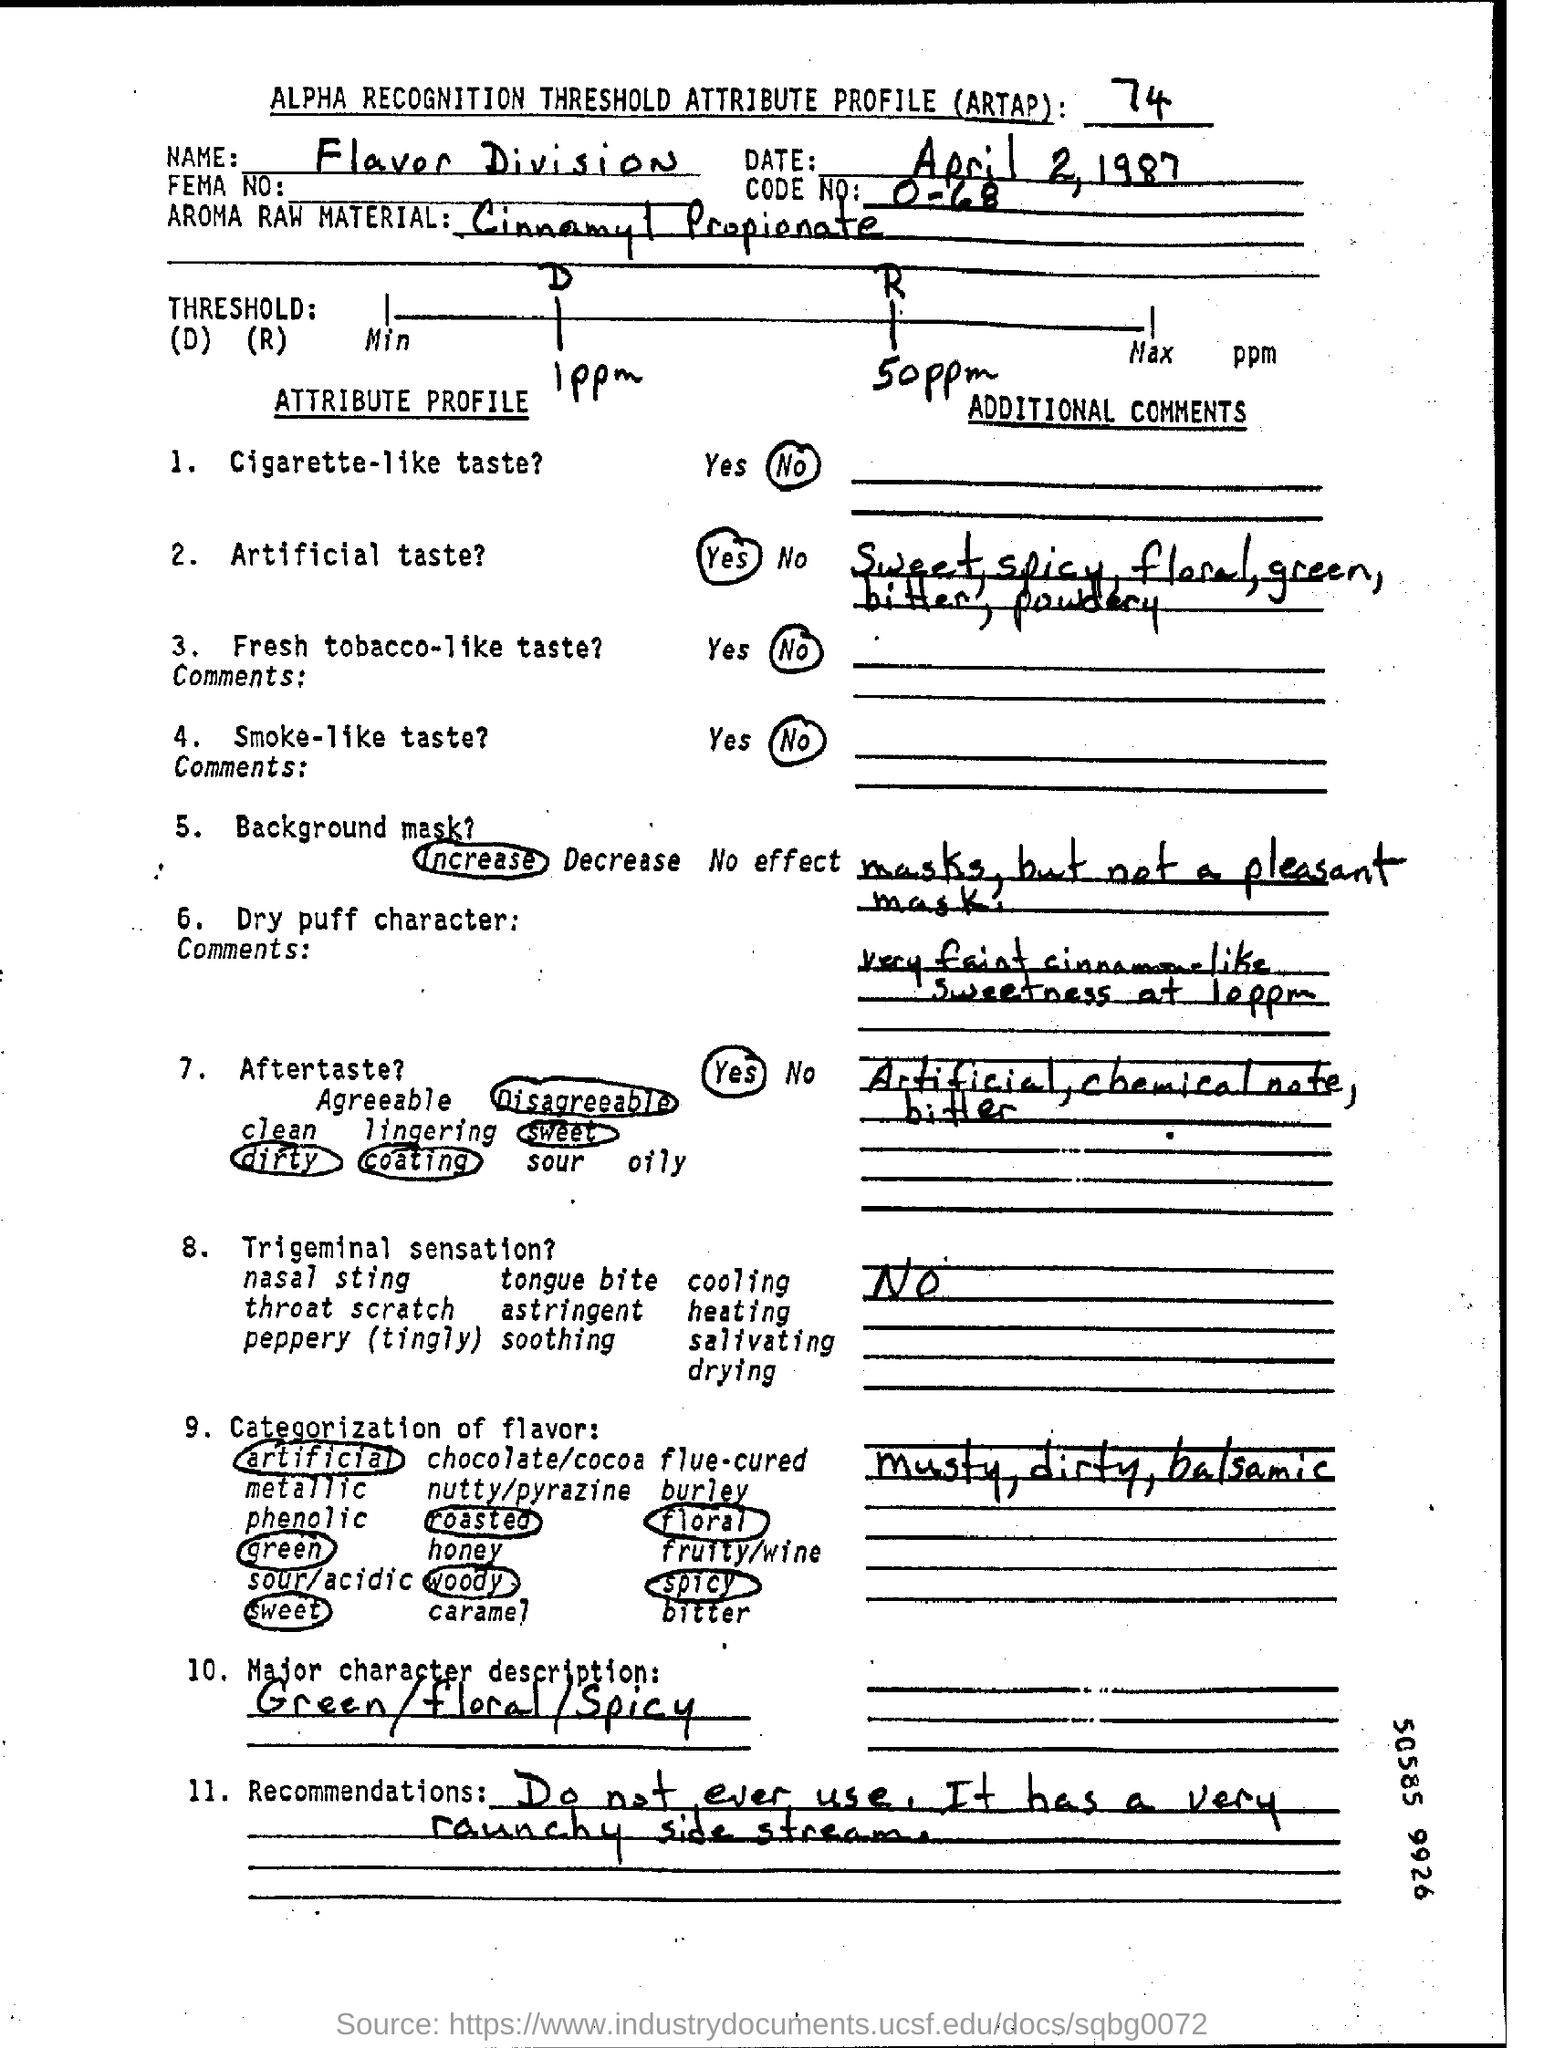What is the Code Number ?
Make the answer very short. 0-68. Which Name written in the Name field ?
Keep it short and to the point. FLAVOR DIVISION. What is written in the Major Character description Field ?
Give a very brief answer. Green/floral/spicy. 